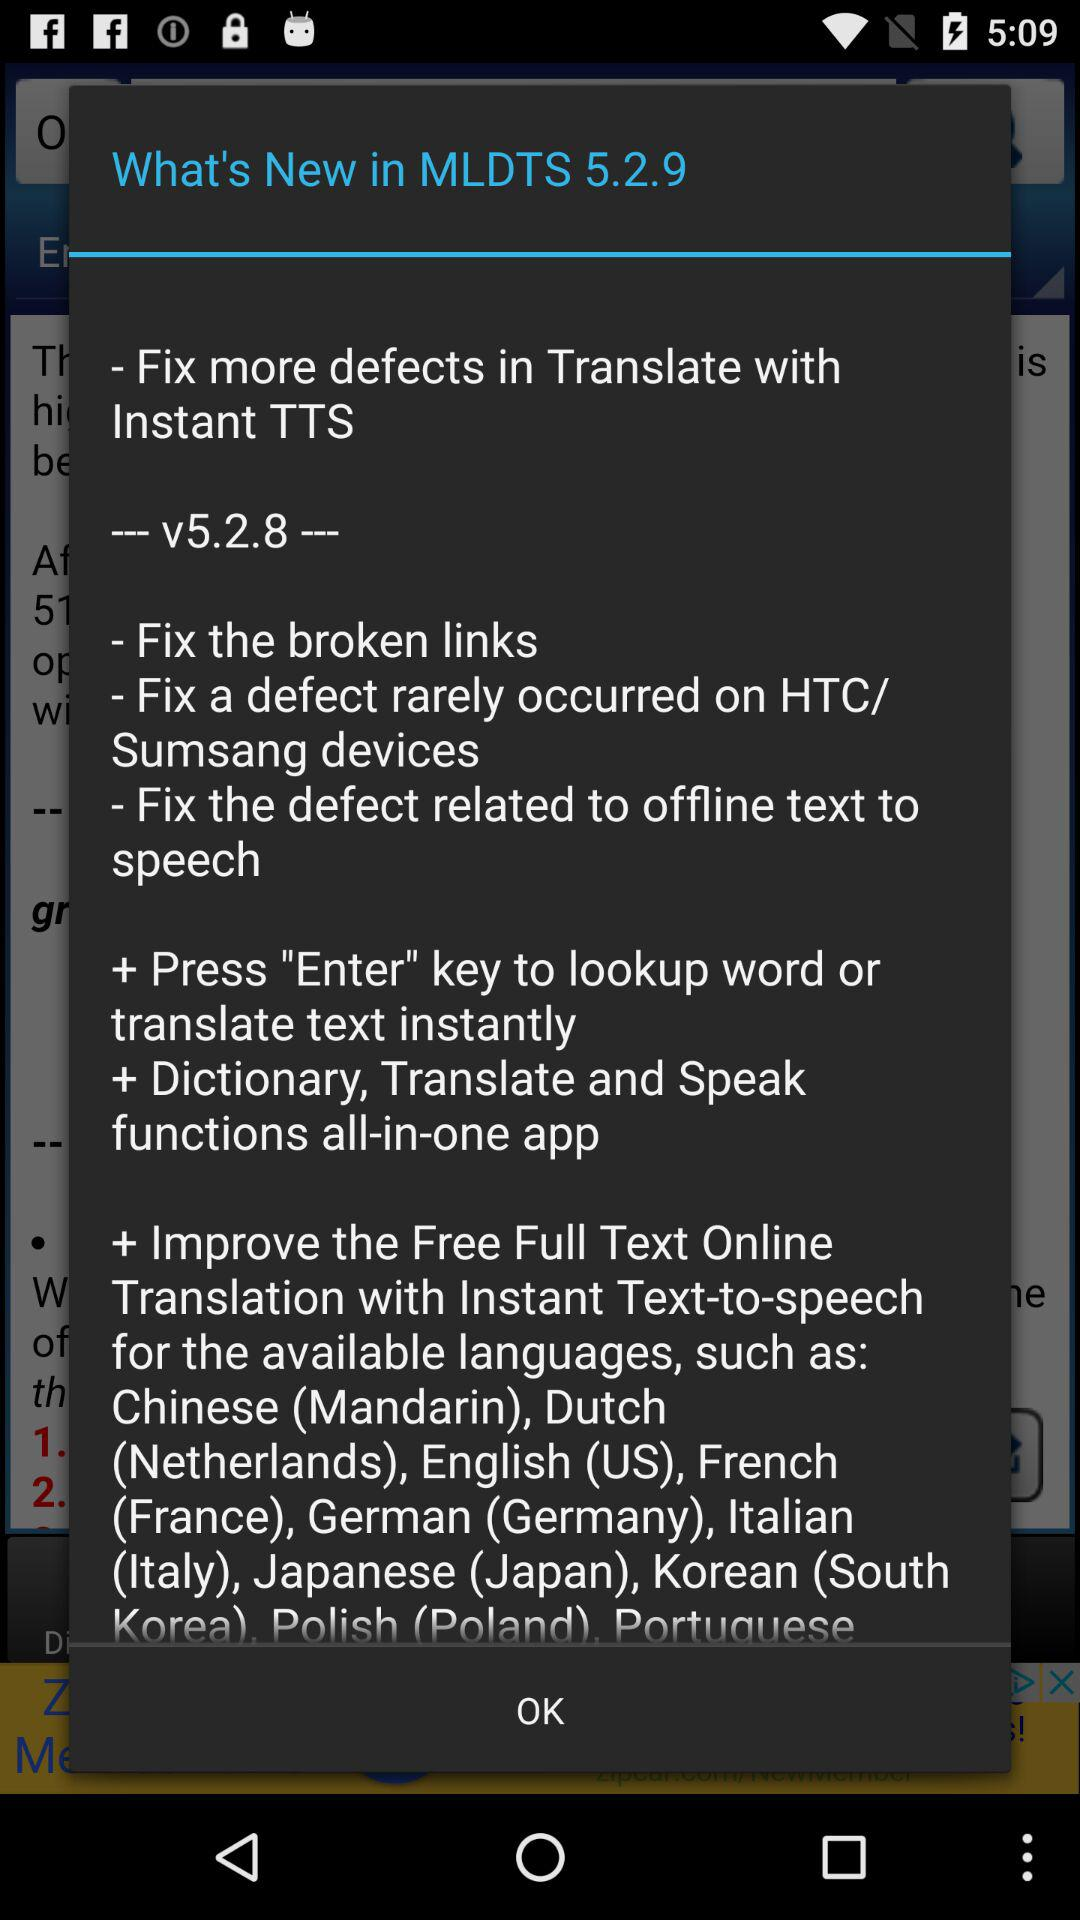How many languages are available in the app?
Answer the question using a single word or phrase. 10 